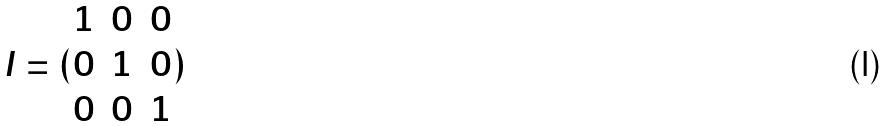Convert formula to latex. <formula><loc_0><loc_0><loc_500><loc_500>I = ( \begin{matrix} 1 & 0 & 0 \\ 0 & 1 & 0 \\ 0 & 0 & 1 \\ \end{matrix} )</formula> 